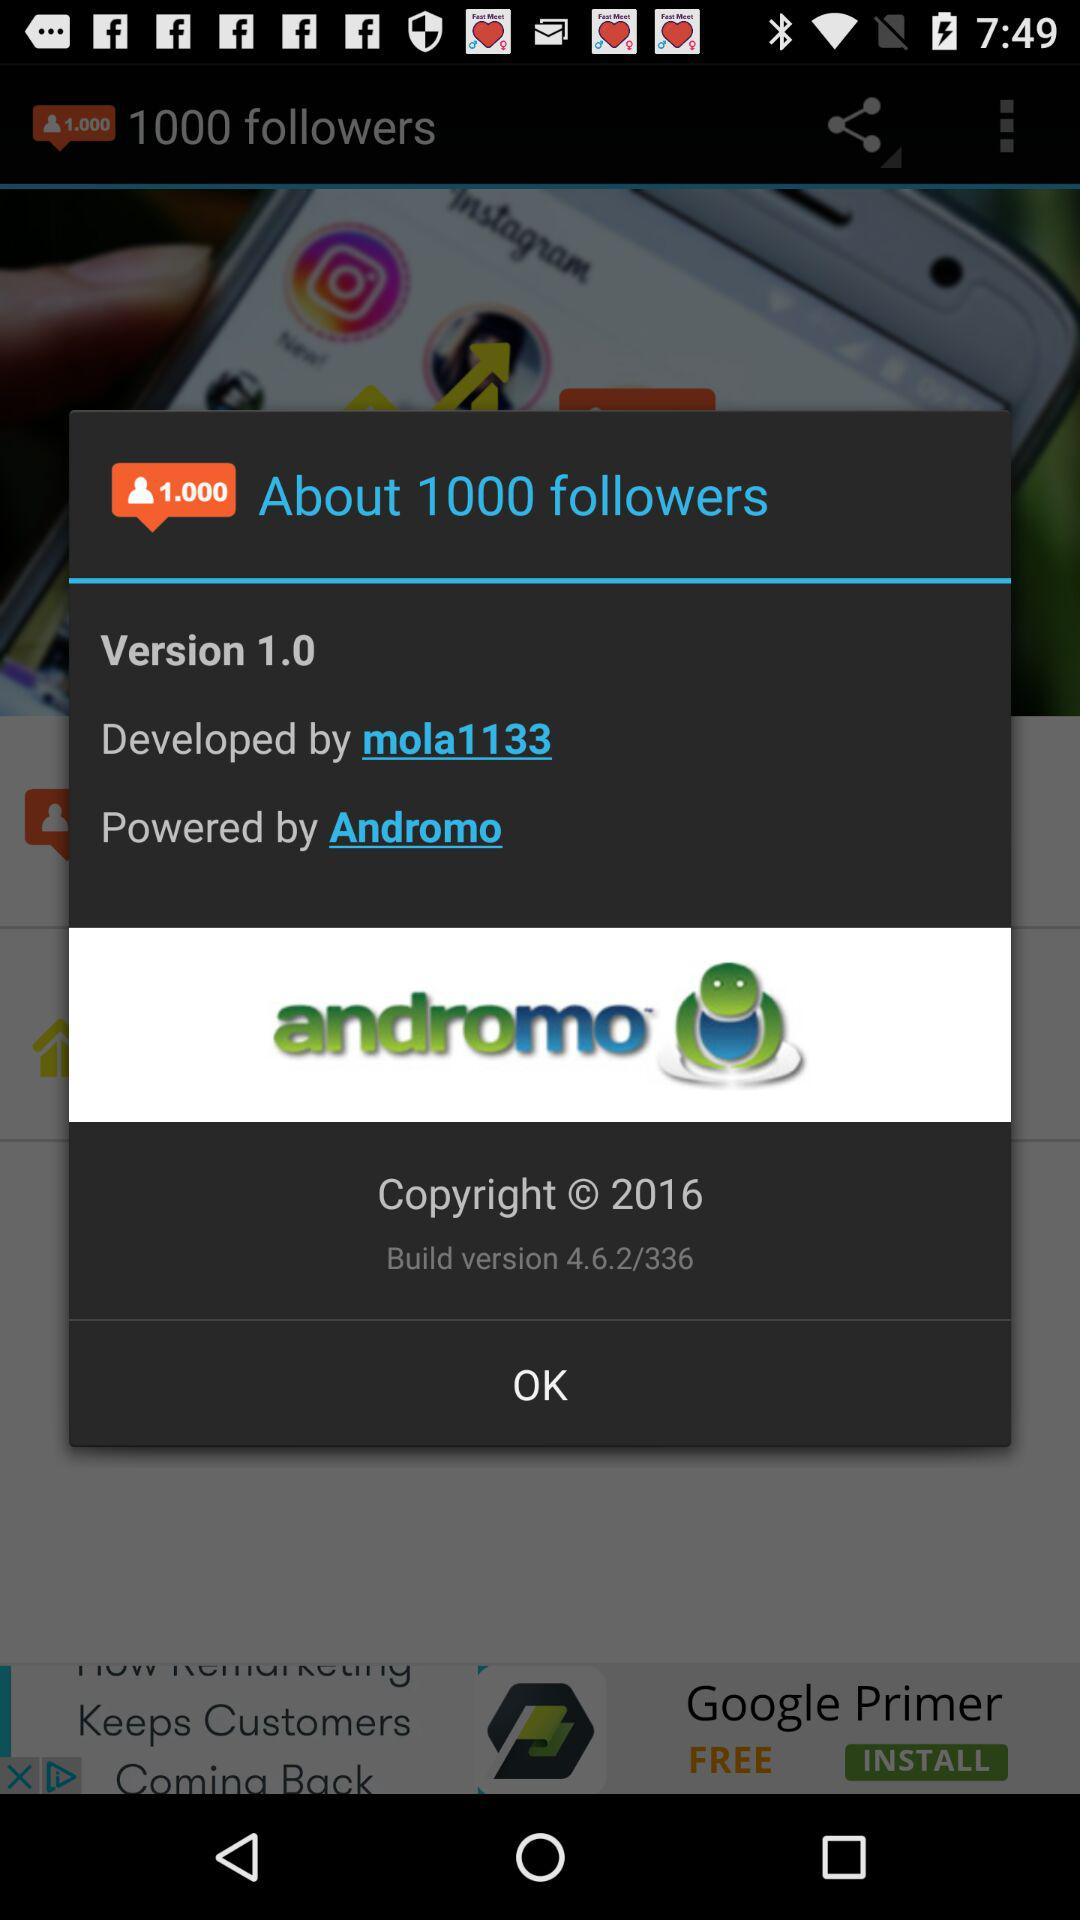What build version of the application is this? The build version of the application is 4.6.2/336. 